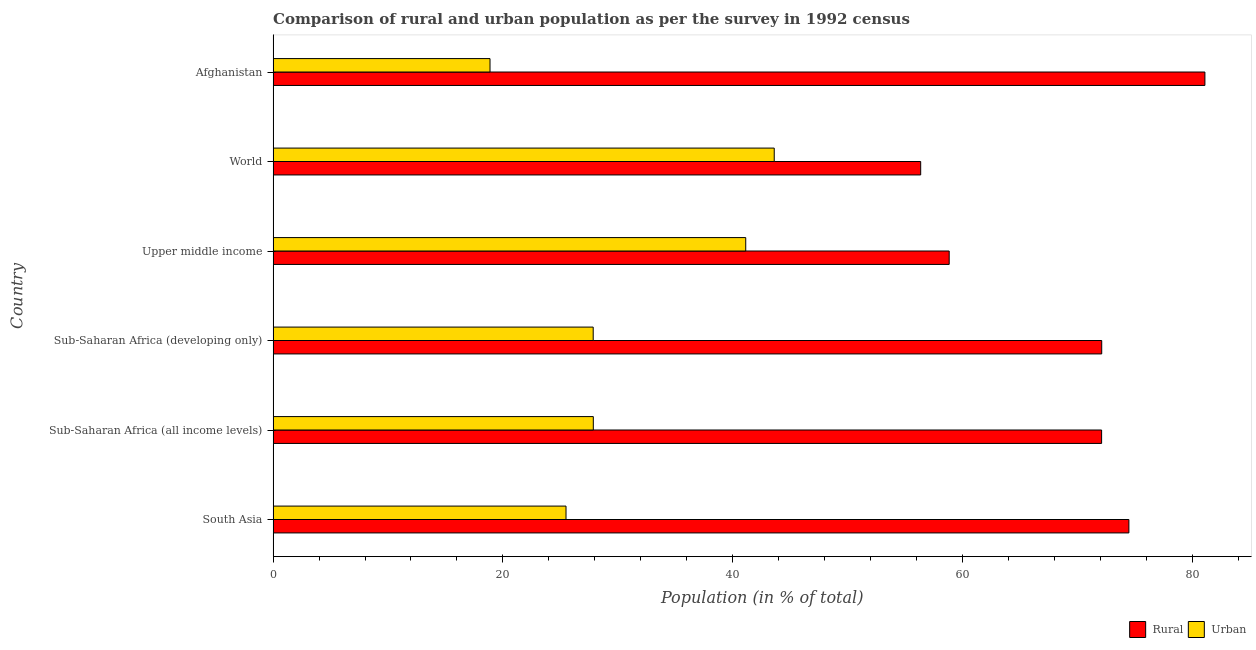How many groups of bars are there?
Ensure brevity in your answer.  6. Are the number of bars per tick equal to the number of legend labels?
Make the answer very short. Yes. Are the number of bars on each tick of the Y-axis equal?
Ensure brevity in your answer.  Yes. How many bars are there on the 1st tick from the top?
Your answer should be very brief. 2. How many bars are there on the 2nd tick from the bottom?
Your answer should be very brief. 2. What is the label of the 1st group of bars from the top?
Provide a succinct answer. Afghanistan. In how many cases, is the number of bars for a given country not equal to the number of legend labels?
Your answer should be compact. 0. What is the urban population in Afghanistan?
Ensure brevity in your answer.  18.88. Across all countries, what is the maximum urban population?
Ensure brevity in your answer.  43.62. Across all countries, what is the minimum urban population?
Give a very brief answer. 18.88. In which country was the rural population maximum?
Make the answer very short. Afghanistan. In which country was the urban population minimum?
Give a very brief answer. Afghanistan. What is the total urban population in the graph?
Make the answer very short. 184.89. What is the difference between the urban population in Sub-Saharan Africa (all income levels) and that in Upper middle income?
Give a very brief answer. -13.27. What is the difference between the urban population in South Asia and the rural population in Upper middle income?
Offer a very short reply. -33.36. What is the average urban population per country?
Your answer should be very brief. 30.82. What is the difference between the rural population and urban population in World?
Your response must be concise. 12.75. What is the ratio of the rural population in Sub-Saharan Africa (all income levels) to that in World?
Make the answer very short. 1.28. Is the difference between the urban population in South Asia and Sub-Saharan Africa (all income levels) greater than the difference between the rural population in South Asia and Sub-Saharan Africa (all income levels)?
Provide a short and direct response. No. What is the difference between the highest and the second highest rural population?
Provide a succinct answer. 6.62. What is the difference between the highest and the lowest rural population?
Ensure brevity in your answer.  24.74. In how many countries, is the urban population greater than the average urban population taken over all countries?
Your response must be concise. 2. Is the sum of the urban population in Sub-Saharan Africa (all income levels) and Upper middle income greater than the maximum rural population across all countries?
Ensure brevity in your answer.  No. What does the 1st bar from the top in Upper middle income represents?
Your answer should be very brief. Urban. What does the 1st bar from the bottom in Sub-Saharan Africa (developing only) represents?
Your answer should be very brief. Rural. How many countries are there in the graph?
Offer a terse response. 6. Are the values on the major ticks of X-axis written in scientific E-notation?
Give a very brief answer. No. Does the graph contain any zero values?
Make the answer very short. No. What is the title of the graph?
Offer a terse response. Comparison of rural and urban population as per the survey in 1992 census. What is the label or title of the X-axis?
Provide a short and direct response. Population (in % of total). What is the label or title of the Y-axis?
Your response must be concise. Country. What is the Population (in % of total) in Rural in South Asia?
Provide a succinct answer. 74.5. What is the Population (in % of total) in Urban in South Asia?
Your response must be concise. 25.5. What is the Population (in % of total) of Rural in Sub-Saharan Africa (all income levels)?
Keep it short and to the point. 72.13. What is the Population (in % of total) of Urban in Sub-Saharan Africa (all income levels)?
Your answer should be compact. 27.87. What is the Population (in % of total) of Rural in Sub-Saharan Africa (developing only)?
Your answer should be compact. 72.13. What is the Population (in % of total) in Urban in Sub-Saharan Africa (developing only)?
Give a very brief answer. 27.87. What is the Population (in % of total) in Rural in Upper middle income?
Your answer should be very brief. 58.86. What is the Population (in % of total) in Urban in Upper middle income?
Provide a succinct answer. 41.14. What is the Population (in % of total) in Rural in World?
Ensure brevity in your answer.  56.38. What is the Population (in % of total) in Urban in World?
Offer a terse response. 43.62. What is the Population (in % of total) of Rural in Afghanistan?
Give a very brief answer. 81.12. What is the Population (in % of total) in Urban in Afghanistan?
Offer a terse response. 18.88. Across all countries, what is the maximum Population (in % of total) in Rural?
Your response must be concise. 81.12. Across all countries, what is the maximum Population (in % of total) of Urban?
Make the answer very short. 43.62. Across all countries, what is the minimum Population (in % of total) in Rural?
Your answer should be compact. 56.38. Across all countries, what is the minimum Population (in % of total) of Urban?
Provide a succinct answer. 18.88. What is the total Population (in % of total) in Rural in the graph?
Keep it short and to the point. 415.11. What is the total Population (in % of total) in Urban in the graph?
Offer a terse response. 184.89. What is the difference between the Population (in % of total) of Rural in South Asia and that in Sub-Saharan Africa (all income levels)?
Give a very brief answer. 2.38. What is the difference between the Population (in % of total) of Urban in South Asia and that in Sub-Saharan Africa (all income levels)?
Your answer should be very brief. -2.38. What is the difference between the Population (in % of total) of Rural in South Asia and that in Sub-Saharan Africa (developing only)?
Your answer should be compact. 2.37. What is the difference between the Population (in % of total) of Urban in South Asia and that in Sub-Saharan Africa (developing only)?
Offer a terse response. -2.37. What is the difference between the Population (in % of total) of Rural in South Asia and that in Upper middle income?
Your answer should be compact. 15.64. What is the difference between the Population (in % of total) in Urban in South Asia and that in Upper middle income?
Your answer should be compact. -15.64. What is the difference between the Population (in % of total) in Rural in South Asia and that in World?
Provide a succinct answer. 18.13. What is the difference between the Population (in % of total) of Urban in South Asia and that in World?
Offer a very short reply. -18.13. What is the difference between the Population (in % of total) of Rural in South Asia and that in Afghanistan?
Keep it short and to the point. -6.62. What is the difference between the Population (in % of total) in Urban in South Asia and that in Afghanistan?
Your answer should be very brief. 6.62. What is the difference between the Population (in % of total) in Rural in Sub-Saharan Africa (all income levels) and that in Sub-Saharan Africa (developing only)?
Offer a very short reply. -0.01. What is the difference between the Population (in % of total) in Urban in Sub-Saharan Africa (all income levels) and that in Sub-Saharan Africa (developing only)?
Ensure brevity in your answer.  0.01. What is the difference between the Population (in % of total) in Rural in Sub-Saharan Africa (all income levels) and that in Upper middle income?
Provide a succinct answer. 13.27. What is the difference between the Population (in % of total) of Urban in Sub-Saharan Africa (all income levels) and that in Upper middle income?
Your answer should be very brief. -13.27. What is the difference between the Population (in % of total) of Rural in Sub-Saharan Africa (all income levels) and that in World?
Keep it short and to the point. 15.75. What is the difference between the Population (in % of total) in Urban in Sub-Saharan Africa (all income levels) and that in World?
Your answer should be very brief. -15.75. What is the difference between the Population (in % of total) in Rural in Sub-Saharan Africa (all income levels) and that in Afghanistan?
Provide a short and direct response. -8.99. What is the difference between the Population (in % of total) of Urban in Sub-Saharan Africa (all income levels) and that in Afghanistan?
Your response must be concise. 8.99. What is the difference between the Population (in % of total) of Rural in Sub-Saharan Africa (developing only) and that in Upper middle income?
Offer a terse response. 13.28. What is the difference between the Population (in % of total) in Urban in Sub-Saharan Africa (developing only) and that in Upper middle income?
Make the answer very short. -13.28. What is the difference between the Population (in % of total) of Rural in Sub-Saharan Africa (developing only) and that in World?
Ensure brevity in your answer.  15.76. What is the difference between the Population (in % of total) in Urban in Sub-Saharan Africa (developing only) and that in World?
Your answer should be compact. -15.76. What is the difference between the Population (in % of total) in Rural in Sub-Saharan Africa (developing only) and that in Afghanistan?
Your answer should be compact. -8.98. What is the difference between the Population (in % of total) of Urban in Sub-Saharan Africa (developing only) and that in Afghanistan?
Ensure brevity in your answer.  8.98. What is the difference between the Population (in % of total) of Rural in Upper middle income and that in World?
Provide a succinct answer. 2.48. What is the difference between the Population (in % of total) of Urban in Upper middle income and that in World?
Give a very brief answer. -2.48. What is the difference between the Population (in % of total) in Rural in Upper middle income and that in Afghanistan?
Make the answer very short. -22.26. What is the difference between the Population (in % of total) of Urban in Upper middle income and that in Afghanistan?
Provide a succinct answer. 22.26. What is the difference between the Population (in % of total) in Rural in World and that in Afghanistan?
Your response must be concise. -24.74. What is the difference between the Population (in % of total) of Urban in World and that in Afghanistan?
Provide a short and direct response. 24.74. What is the difference between the Population (in % of total) of Rural in South Asia and the Population (in % of total) of Urban in Sub-Saharan Africa (all income levels)?
Your response must be concise. 46.63. What is the difference between the Population (in % of total) of Rural in South Asia and the Population (in % of total) of Urban in Sub-Saharan Africa (developing only)?
Your answer should be very brief. 46.64. What is the difference between the Population (in % of total) in Rural in South Asia and the Population (in % of total) in Urban in Upper middle income?
Your response must be concise. 33.36. What is the difference between the Population (in % of total) of Rural in South Asia and the Population (in % of total) of Urban in World?
Offer a terse response. 30.88. What is the difference between the Population (in % of total) in Rural in South Asia and the Population (in % of total) in Urban in Afghanistan?
Your answer should be very brief. 55.62. What is the difference between the Population (in % of total) in Rural in Sub-Saharan Africa (all income levels) and the Population (in % of total) in Urban in Sub-Saharan Africa (developing only)?
Give a very brief answer. 44.26. What is the difference between the Population (in % of total) of Rural in Sub-Saharan Africa (all income levels) and the Population (in % of total) of Urban in Upper middle income?
Offer a very short reply. 30.98. What is the difference between the Population (in % of total) of Rural in Sub-Saharan Africa (all income levels) and the Population (in % of total) of Urban in World?
Offer a very short reply. 28.5. What is the difference between the Population (in % of total) in Rural in Sub-Saharan Africa (all income levels) and the Population (in % of total) in Urban in Afghanistan?
Give a very brief answer. 53.24. What is the difference between the Population (in % of total) in Rural in Sub-Saharan Africa (developing only) and the Population (in % of total) in Urban in Upper middle income?
Offer a terse response. 30.99. What is the difference between the Population (in % of total) in Rural in Sub-Saharan Africa (developing only) and the Population (in % of total) in Urban in World?
Your answer should be compact. 28.51. What is the difference between the Population (in % of total) of Rural in Sub-Saharan Africa (developing only) and the Population (in % of total) of Urban in Afghanistan?
Your answer should be compact. 53.25. What is the difference between the Population (in % of total) of Rural in Upper middle income and the Population (in % of total) of Urban in World?
Keep it short and to the point. 15.23. What is the difference between the Population (in % of total) in Rural in Upper middle income and the Population (in % of total) in Urban in Afghanistan?
Offer a very short reply. 39.97. What is the difference between the Population (in % of total) in Rural in World and the Population (in % of total) in Urban in Afghanistan?
Keep it short and to the point. 37.49. What is the average Population (in % of total) in Rural per country?
Provide a short and direct response. 69.19. What is the average Population (in % of total) in Urban per country?
Ensure brevity in your answer.  30.82. What is the difference between the Population (in % of total) in Rural and Population (in % of total) in Urban in South Asia?
Your answer should be compact. 49. What is the difference between the Population (in % of total) of Rural and Population (in % of total) of Urban in Sub-Saharan Africa (all income levels)?
Provide a short and direct response. 44.25. What is the difference between the Population (in % of total) of Rural and Population (in % of total) of Urban in Sub-Saharan Africa (developing only)?
Your answer should be very brief. 44.27. What is the difference between the Population (in % of total) of Rural and Population (in % of total) of Urban in Upper middle income?
Your answer should be compact. 17.71. What is the difference between the Population (in % of total) of Rural and Population (in % of total) of Urban in World?
Your answer should be compact. 12.75. What is the difference between the Population (in % of total) of Rural and Population (in % of total) of Urban in Afghanistan?
Your answer should be very brief. 62.24. What is the ratio of the Population (in % of total) in Rural in South Asia to that in Sub-Saharan Africa (all income levels)?
Make the answer very short. 1.03. What is the ratio of the Population (in % of total) in Urban in South Asia to that in Sub-Saharan Africa (all income levels)?
Offer a terse response. 0.91. What is the ratio of the Population (in % of total) of Rural in South Asia to that in Sub-Saharan Africa (developing only)?
Give a very brief answer. 1.03. What is the ratio of the Population (in % of total) in Urban in South Asia to that in Sub-Saharan Africa (developing only)?
Offer a very short reply. 0.92. What is the ratio of the Population (in % of total) of Rural in South Asia to that in Upper middle income?
Your response must be concise. 1.27. What is the ratio of the Population (in % of total) of Urban in South Asia to that in Upper middle income?
Offer a terse response. 0.62. What is the ratio of the Population (in % of total) in Rural in South Asia to that in World?
Offer a terse response. 1.32. What is the ratio of the Population (in % of total) in Urban in South Asia to that in World?
Give a very brief answer. 0.58. What is the ratio of the Population (in % of total) in Rural in South Asia to that in Afghanistan?
Give a very brief answer. 0.92. What is the ratio of the Population (in % of total) in Urban in South Asia to that in Afghanistan?
Keep it short and to the point. 1.35. What is the ratio of the Population (in % of total) in Rural in Sub-Saharan Africa (all income levels) to that in Sub-Saharan Africa (developing only)?
Ensure brevity in your answer.  1. What is the ratio of the Population (in % of total) in Rural in Sub-Saharan Africa (all income levels) to that in Upper middle income?
Ensure brevity in your answer.  1.23. What is the ratio of the Population (in % of total) in Urban in Sub-Saharan Africa (all income levels) to that in Upper middle income?
Provide a succinct answer. 0.68. What is the ratio of the Population (in % of total) in Rural in Sub-Saharan Africa (all income levels) to that in World?
Make the answer very short. 1.28. What is the ratio of the Population (in % of total) of Urban in Sub-Saharan Africa (all income levels) to that in World?
Give a very brief answer. 0.64. What is the ratio of the Population (in % of total) of Rural in Sub-Saharan Africa (all income levels) to that in Afghanistan?
Provide a succinct answer. 0.89. What is the ratio of the Population (in % of total) of Urban in Sub-Saharan Africa (all income levels) to that in Afghanistan?
Provide a succinct answer. 1.48. What is the ratio of the Population (in % of total) in Rural in Sub-Saharan Africa (developing only) to that in Upper middle income?
Keep it short and to the point. 1.23. What is the ratio of the Population (in % of total) of Urban in Sub-Saharan Africa (developing only) to that in Upper middle income?
Keep it short and to the point. 0.68. What is the ratio of the Population (in % of total) in Rural in Sub-Saharan Africa (developing only) to that in World?
Your answer should be very brief. 1.28. What is the ratio of the Population (in % of total) in Urban in Sub-Saharan Africa (developing only) to that in World?
Your answer should be very brief. 0.64. What is the ratio of the Population (in % of total) in Rural in Sub-Saharan Africa (developing only) to that in Afghanistan?
Offer a very short reply. 0.89. What is the ratio of the Population (in % of total) of Urban in Sub-Saharan Africa (developing only) to that in Afghanistan?
Provide a succinct answer. 1.48. What is the ratio of the Population (in % of total) of Rural in Upper middle income to that in World?
Keep it short and to the point. 1.04. What is the ratio of the Population (in % of total) of Urban in Upper middle income to that in World?
Make the answer very short. 0.94. What is the ratio of the Population (in % of total) in Rural in Upper middle income to that in Afghanistan?
Your answer should be very brief. 0.73. What is the ratio of the Population (in % of total) in Urban in Upper middle income to that in Afghanistan?
Offer a terse response. 2.18. What is the ratio of the Population (in % of total) in Rural in World to that in Afghanistan?
Make the answer very short. 0.69. What is the ratio of the Population (in % of total) of Urban in World to that in Afghanistan?
Offer a terse response. 2.31. What is the difference between the highest and the second highest Population (in % of total) of Rural?
Your response must be concise. 6.62. What is the difference between the highest and the second highest Population (in % of total) in Urban?
Give a very brief answer. 2.48. What is the difference between the highest and the lowest Population (in % of total) in Rural?
Provide a short and direct response. 24.74. What is the difference between the highest and the lowest Population (in % of total) of Urban?
Ensure brevity in your answer.  24.74. 